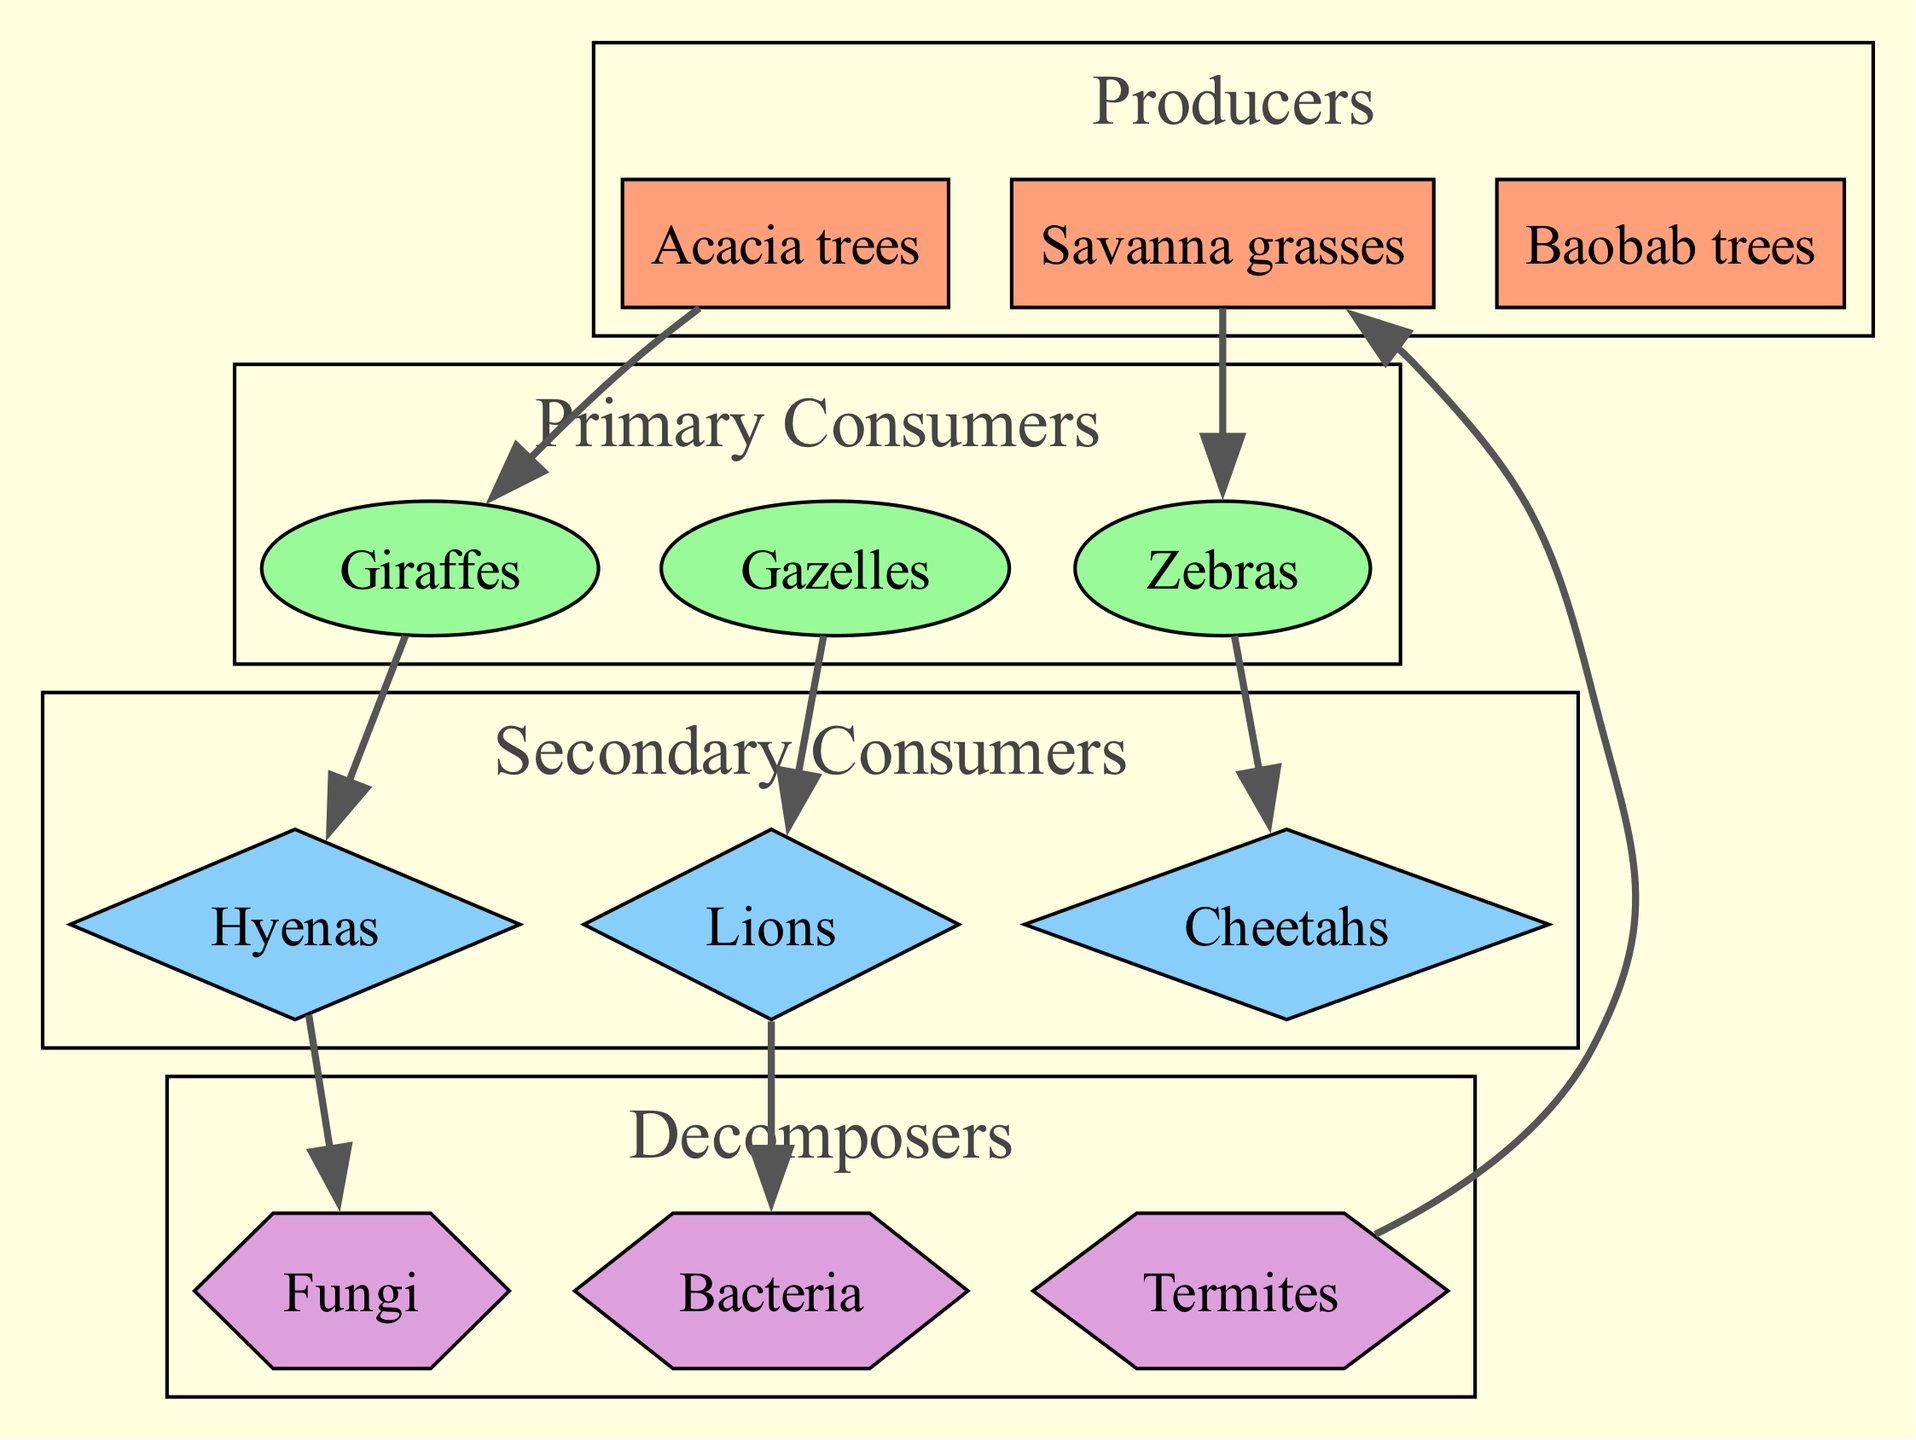What are the producers in this food chain? The producers are the organisms that produce energy through photosynthesis. In the diagram, we see "Savanna grasses", "Acacia trees", and "Baobab trees" listed under the producers.
Answer: Savanna grasses, Acacia trees, Baobab trees How many primary consumers are there? The primary consumers in the diagram are "Zebras", "Gazelles", and "Giraffes". Counting these, we find there are three primary consumers listed in the diagram.
Answer: 3 Which secondary consumer is connected directly to Gazelles? The connection reads "Gazelles → Lions". This indicates that Lions are the secondary consumers that feed directly on Gazelles. Therefore, Lions are connected directly to Gazelles in the food chain.
Answer: Lions What do Hyenas consume according to the diagram? The diagram shows the connection "Giraffes → Hyenas", indicating that Hyenas consume Giraffes. This means the primary food source for Hyenas listed in the diagram is Giraffes.
Answer: Giraffes Which decomposer is linked to Lions? The connection "Lions → Bacteria" shows that Lions are linked to Bacteria. This means that Bacteria are the decomposers that decompose the remains of Lions in the ecosystem.
Answer: Bacteria How many decomposers are there? The decomposers listed in the diagram are "Bacteria", "Fungi", and "Termites". Counting these, we find that there are three decomposers present in the food chain.
Answer: 3 Which producer is eaten by Termites? The connection indicates "Termites → Savanna grasses". This means that Savanna grasses are the producers that are consumed by Termites as part of the food chain.
Answer: Savanna grasses Which two secondary consumers are connected to Giraffes? According to the connections, Giraffes are linked to "Hyenas". However, no other secondary consumer is directly connected to Giraffes in the provided information. Therefore, the answer to this question about the two secondary consumers would indicate that Hyenas are the only one mentioned.
Answer: Hyenas 